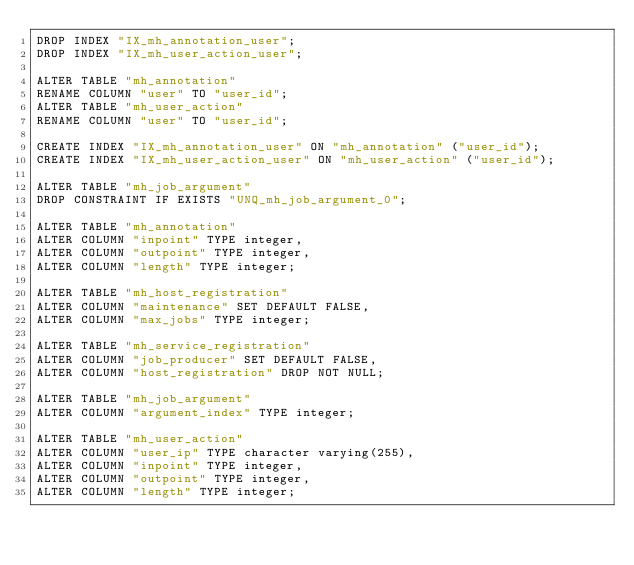Convert code to text. <code><loc_0><loc_0><loc_500><loc_500><_SQL_>DROP INDEX "IX_mh_annotation_user";
DROP INDEX "IX_mh_user_action_user";

ALTER TABLE "mh_annotation"
RENAME COLUMN "user" TO "user_id";
ALTER TABLE "mh_user_action"
RENAME COLUMN "user" TO "user_id";

CREATE INDEX "IX_mh_annotation_user" ON "mh_annotation" ("user_id");
CREATE INDEX "IX_mh_user_action_user" ON "mh_user_action" ("user_id");

ALTER TABLE "mh_job_argument"
DROP CONSTRAINT IF EXISTS "UNQ_mh_job_argument_0";

ALTER TABLE "mh_annotation"
ALTER COLUMN "inpoint" TYPE integer,
ALTER COLUMN "outpoint" TYPE integer,
ALTER COLUMN "length" TYPE integer;

ALTER TABLE "mh_host_registration"
ALTER COLUMN "maintenance" SET DEFAULT FALSE,
ALTER COLUMN "max_jobs" TYPE integer;

ALTER TABLE "mh_service_registration"
ALTER COLUMN "job_producer" SET DEFAULT FALSE,
ALTER COLUMN "host_registration" DROP NOT NULL;

ALTER TABLE "mh_job_argument"
ALTER COLUMN "argument_index" TYPE integer;

ALTER TABLE "mh_user_action"
ALTER COLUMN "user_ip" TYPE character varying(255),
ALTER COLUMN "inpoint" TYPE integer,
ALTER COLUMN "outpoint" TYPE integer,
ALTER COLUMN "length" TYPE integer;
</code> 